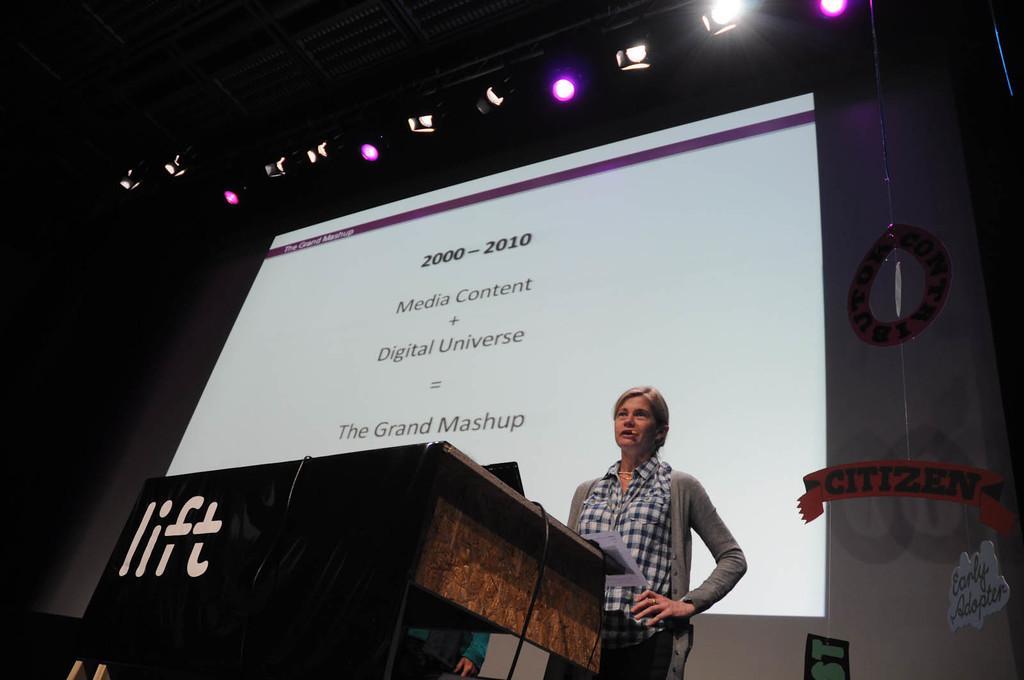In one or two sentences, can you explain what this image depicts? To the bottom middle of the image there is a podium with wires and a name on it. In front of the podium there is a lady with grey jacket and black and white checks shirt is standing and there is a mic to her. Behind the lady there is a screen and to the top of the image there are lights to the roof. 